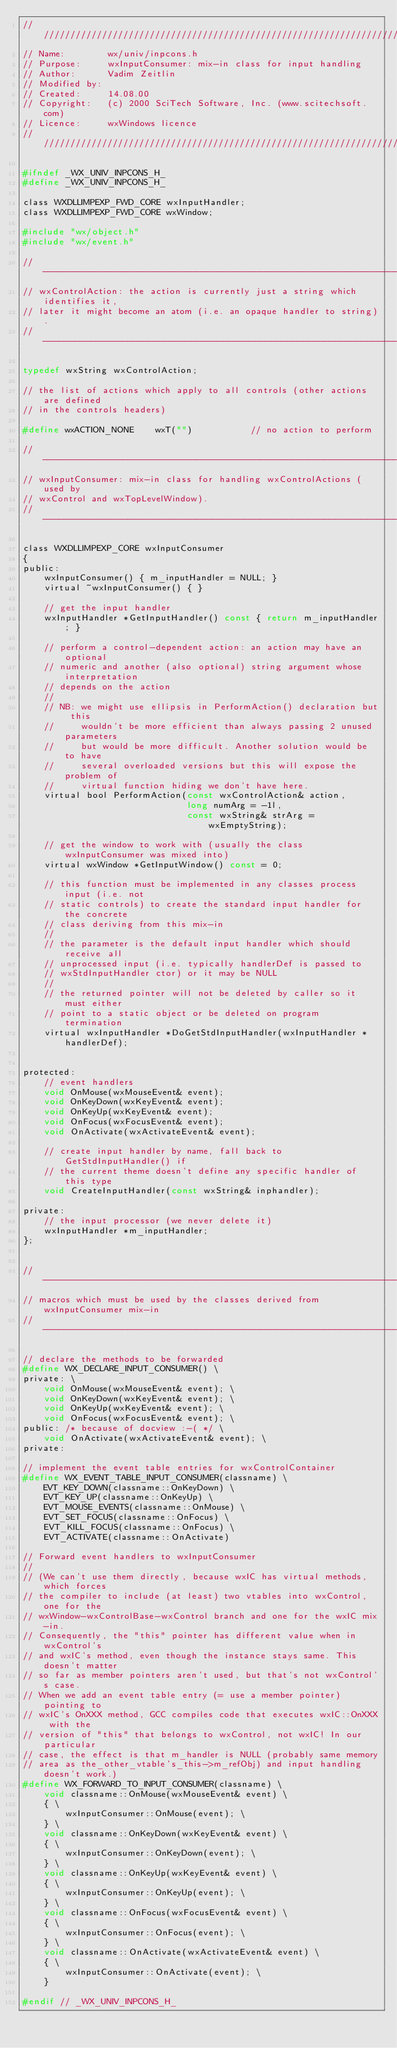<code> <loc_0><loc_0><loc_500><loc_500><_C_>/////////////////////////////////////////////////////////////////////////////
// Name:        wx/univ/inpcons.h
// Purpose:     wxInputConsumer: mix-in class for input handling
// Author:      Vadim Zeitlin
// Modified by:
// Created:     14.08.00
// Copyright:   (c) 2000 SciTech Software, Inc. (www.scitechsoft.com)
// Licence:     wxWindows licence
/////////////////////////////////////////////////////////////////////////////

#ifndef _WX_UNIV_INPCONS_H_
#define _WX_UNIV_INPCONS_H_

class WXDLLIMPEXP_FWD_CORE wxInputHandler;
class WXDLLIMPEXP_FWD_CORE wxWindow;

#include "wx/object.h"
#include "wx/event.h"

// ----------------------------------------------------------------------------
// wxControlAction: the action is currently just a string which identifies it,
// later it might become an atom (i.e. an opaque handler to string).
// ----------------------------------------------------------------------------

typedef wxString wxControlAction;

// the list of actions which apply to all controls (other actions are defined
// in the controls headers)

#define wxACTION_NONE    wxT("")           // no action to perform

// ----------------------------------------------------------------------------
// wxInputConsumer: mix-in class for handling wxControlActions (used by
// wxControl and wxTopLevelWindow).
// ----------------------------------------------------------------------------

class WXDLLIMPEXP_CORE wxInputConsumer
{
public:
    wxInputConsumer() { m_inputHandler = NULL; }
    virtual ~wxInputConsumer() { }

    // get the input handler
    wxInputHandler *GetInputHandler() const { return m_inputHandler; }

    // perform a control-dependent action: an action may have an optional
    // numeric and another (also optional) string argument whose interpretation
    // depends on the action
    //
    // NB: we might use ellipsis in PerformAction() declaration but this
    //     wouldn't be more efficient than always passing 2 unused parameters
    //     but would be more difficult. Another solution would be to have
    //     several overloaded versions but this will expose the problem of
    //     virtual function hiding we don't have here.
    virtual bool PerformAction(const wxControlAction& action,
                               long numArg = -1l,
                               const wxString& strArg = wxEmptyString);

    // get the window to work with (usually the class wxInputConsumer was mixed into)
    virtual wxWindow *GetInputWindow() const = 0;

    // this function must be implemented in any classes process input (i.e. not
    // static controls) to create the standard input handler for the concrete
    // class deriving from this mix-in
    //
    // the parameter is the default input handler which should receive all
    // unprocessed input (i.e. typically handlerDef is passed to
    // wxStdInputHandler ctor) or it may be NULL
    //
    // the returned pointer will not be deleted by caller so it must either
    // point to a static object or be deleted on program termination
    virtual wxInputHandler *DoGetStdInputHandler(wxInputHandler *handlerDef);


protected:
    // event handlers
    void OnMouse(wxMouseEvent& event);
    void OnKeyDown(wxKeyEvent& event);
    void OnKeyUp(wxKeyEvent& event);
    void OnFocus(wxFocusEvent& event);
    void OnActivate(wxActivateEvent& event);

    // create input handler by name, fall back to GetStdInputHandler() if
    // the current theme doesn't define any specific handler of this type
    void CreateInputHandler(const wxString& inphandler);

private:
    // the input processor (we never delete it)
    wxInputHandler *m_inputHandler;
};


// ----------------------------------------------------------------------------
// macros which must be used by the classes derived from wxInputConsumer mix-in
// ----------------------------------------------------------------------------

// declare the methods to be forwarded
#define WX_DECLARE_INPUT_CONSUMER() \
private: \
    void OnMouse(wxMouseEvent& event); \
    void OnKeyDown(wxKeyEvent& event); \
    void OnKeyUp(wxKeyEvent& event); \
    void OnFocus(wxFocusEvent& event); \
public: /* because of docview :-( */ \
    void OnActivate(wxActivateEvent& event); \
private:

// implement the event table entries for wxControlContainer
#define WX_EVENT_TABLE_INPUT_CONSUMER(classname) \
    EVT_KEY_DOWN(classname::OnKeyDown) \
    EVT_KEY_UP(classname::OnKeyUp) \
    EVT_MOUSE_EVENTS(classname::OnMouse) \
    EVT_SET_FOCUS(classname::OnFocus) \
    EVT_KILL_FOCUS(classname::OnFocus) \
    EVT_ACTIVATE(classname::OnActivate)

// Forward event handlers to wxInputConsumer
//
// (We can't use them directly, because wxIC has virtual methods, which forces
// the compiler to include (at least) two vtables into wxControl, one for the
// wxWindow-wxControlBase-wxControl branch and one for the wxIC mix-in.
// Consequently, the "this" pointer has different value when in wxControl's
// and wxIC's method, even though the instance stays same. This doesn't matter
// so far as member pointers aren't used, but that's not wxControl's case.
// When we add an event table entry (= use a member pointer) pointing to
// wxIC's OnXXX method, GCC compiles code that executes wxIC::OnXXX with the
// version of "this" that belongs to wxControl, not wxIC! In our particular
// case, the effect is that m_handler is NULL (probably same memory
// area as the_other_vtable's_this->m_refObj) and input handling doesn't work.)
#define WX_FORWARD_TO_INPUT_CONSUMER(classname) \
    void classname::OnMouse(wxMouseEvent& event) \
    { \
        wxInputConsumer::OnMouse(event); \
    } \
    void classname::OnKeyDown(wxKeyEvent& event) \
    { \
        wxInputConsumer::OnKeyDown(event); \
    } \
    void classname::OnKeyUp(wxKeyEvent& event) \
    { \
        wxInputConsumer::OnKeyUp(event); \
    } \
    void classname::OnFocus(wxFocusEvent& event) \
    { \
        wxInputConsumer::OnFocus(event); \
    } \
    void classname::OnActivate(wxActivateEvent& event) \
    { \
        wxInputConsumer::OnActivate(event); \
    }

#endif // _WX_UNIV_INPCONS_H_
</code> 